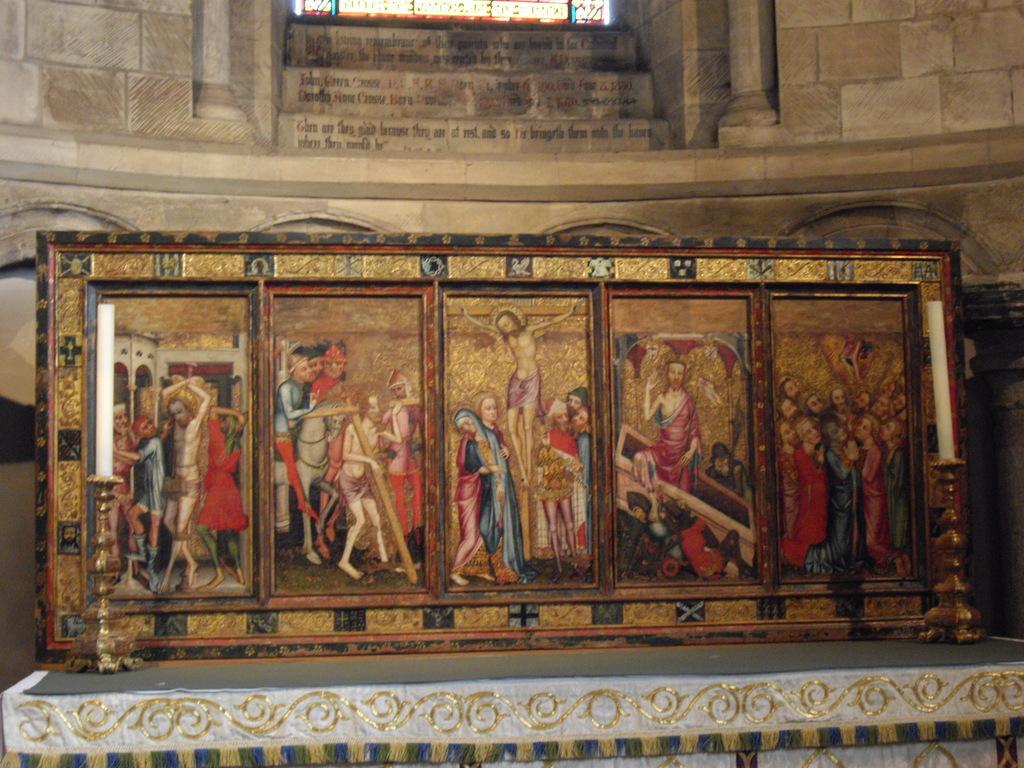Could you give a brief overview of what you see in this image? In this image there is one photo frame is kept on one object and this photo frame is in middle of this image and there is a wall in the background. 